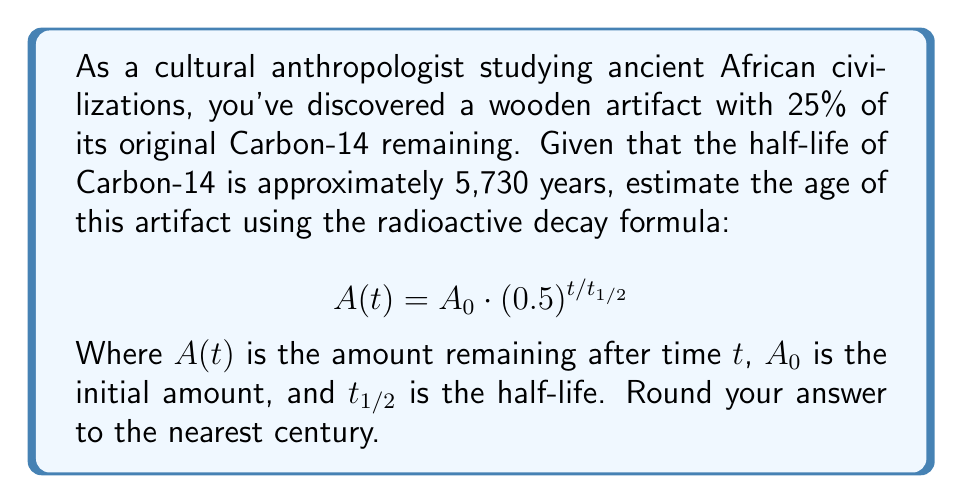Can you answer this question? Let's approach this step-by-step:

1) We know that 25% of the original Carbon-14 remains. This means:
   $A(t) / A_0 = 0.25$

2) We can substitute this into our decay formula:
   $0.25 = (0.5)^{t/5730}$

3) Taking the natural log of both sides:
   $\ln(0.25) = \ln((0.5)^{t/5730})$

4) Using the logarithm property $\ln(x^n) = n\ln(x)$:
   $\ln(0.25) = (t/5730) \cdot \ln(0.5)$

5) Solve for $t$:
   $t = 5730 \cdot \frac{\ln(0.25)}{\ln(0.5)}$

6) Calculate:
   $t = 5730 \cdot \frac{-1.3863}{-0.6931} \approx 11460$ years

7) Rounding to the nearest century:
   11,500 years
Answer: 11,500 years 